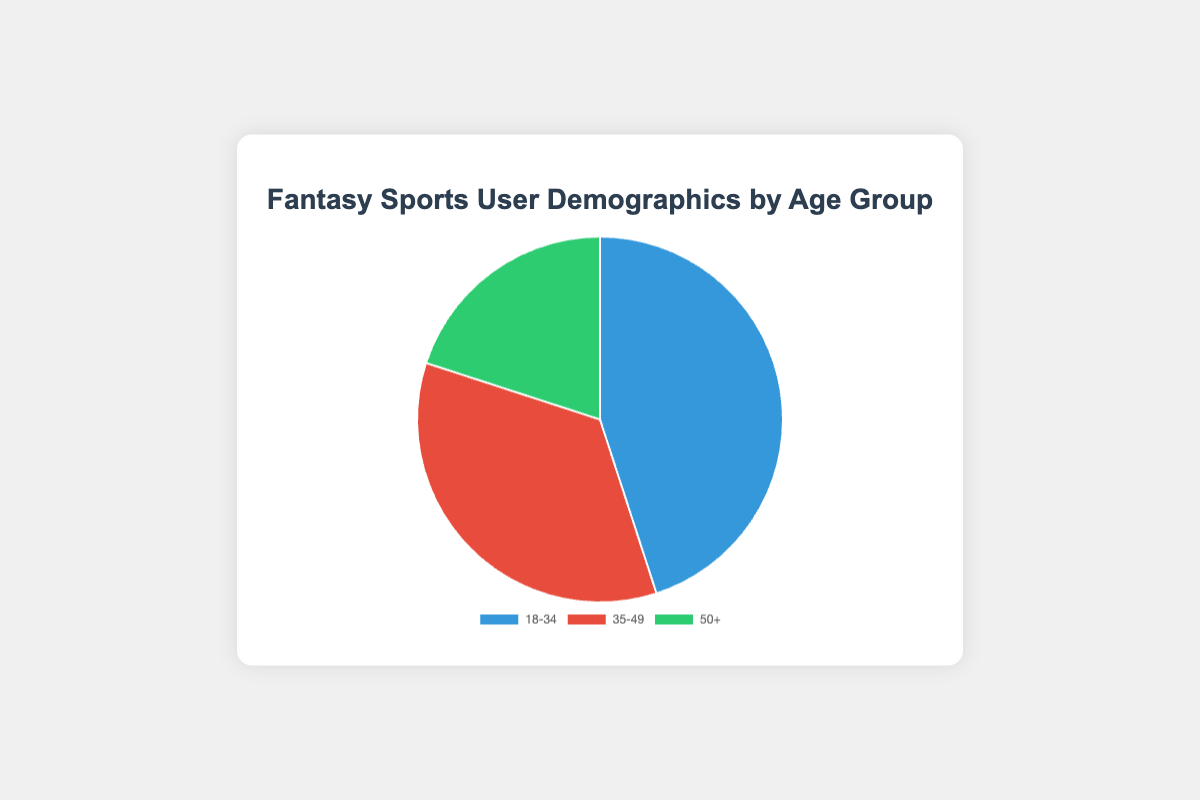What percentage of fantasy sports users are aged 18-34? The pie chart shows the percentage of users in each age group. By looking at the slice labeled 18-34, we see it's 45%.
Answer: 45% What is the total user base for the age groups 35-49 and 50+ combined? To find the total, add the user base for 35-49 (10,500,000) and 50+ (6,000,000). 10,500,000 + 6,000,000 = 16,500,000.
Answer: 16,500,000 Which age group constitutes the smallest proportion of fantasy sports users and what is their percentage? By comparing the size of the slices, the smallest one is for the 50+ age group, which shows as 20%.
Answer: 50+, 20% How much larger is the user base of the 18-34 age group compared to the 50+ age group? Subtract the user base of the 50+ group (6,000,000) from the 18-34 group (13,500,000). 13,500,000 - 6,000,000 = 7,500,000.
Answer: 7,500,000 Which age group predominantly participates in NFL, judging by user percentage? All age groups participate in NFL, but the 18-34 group has the largest percentage of 45%.
Answer: 18-34 How does the percentage of users aged 35-49 compare to the percentage of users aged 50+? The percentage of users aged 35-49 is 35%, whereas the percentage for 50+ is 20%. So, 35-49 is larger.
Answer: 35% is larger What percentage of the overall user base is aged above 50? The pie chart shows the percentage of users aged 50+ as 20%.
Answer: 20% What is the combined percentage for the age groups 18-34 and 35-49? To find the combined percentage, add the percentage for 18-34 (45%) and 35-49 (35%). 45% + 35% = 80%.
Answer: 80% What age group has the second highest user base in fantasy sports? By looking at the pie chart, the second largest slice is the 35-49 age group with a 35% share and a user base of 10,500,000.
Answer: 35-49 